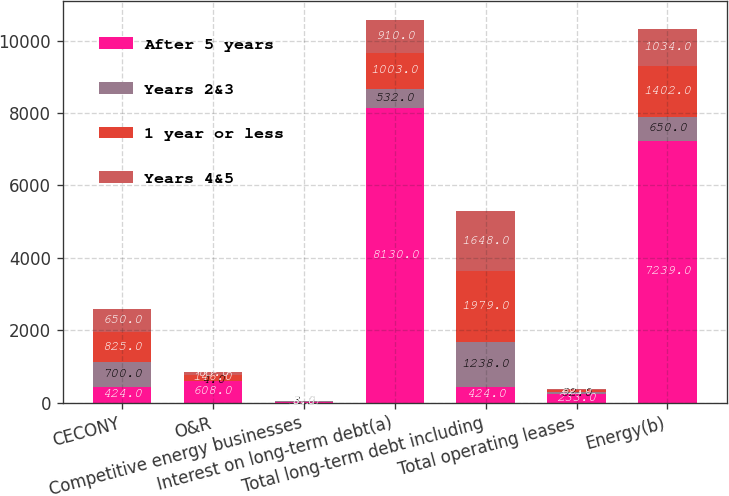Convert chart to OTSL. <chart><loc_0><loc_0><loc_500><loc_500><stacked_bar_chart><ecel><fcel>CECONY<fcel>O&R<fcel>Competitive energy businesses<fcel>Interest on long-term debt(a)<fcel>Total long-term debt including<fcel>Total operating leases<fcel>Energy(b)<nl><fcel>After 5 years<fcel>424<fcel>608<fcel>30<fcel>8130<fcel>424<fcel>233<fcel>7239<nl><fcel>Years 2&3<fcel>700<fcel>4<fcel>3<fcel>532<fcel>1238<fcel>52<fcel>650<nl><fcel>1 year or less<fcel>825<fcel>146<fcel>5<fcel>1003<fcel>1979<fcel>62<fcel>1402<nl><fcel>Years 4&5<fcel>650<fcel>83<fcel>5<fcel>910<fcel>1648<fcel>28<fcel>1034<nl></chart> 